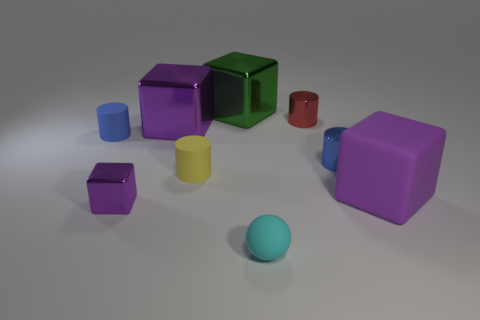Looking at the colors in the image, which one is the most dominant and why might that be the case? The color blue appears to be quite dominant in this image because there are several objects with different shades of blue. This might be due to the choice of the photographer or the person arranging the objects to create a visual theme or to provide a calming effect, as blue is often associated with calmness and stability. 